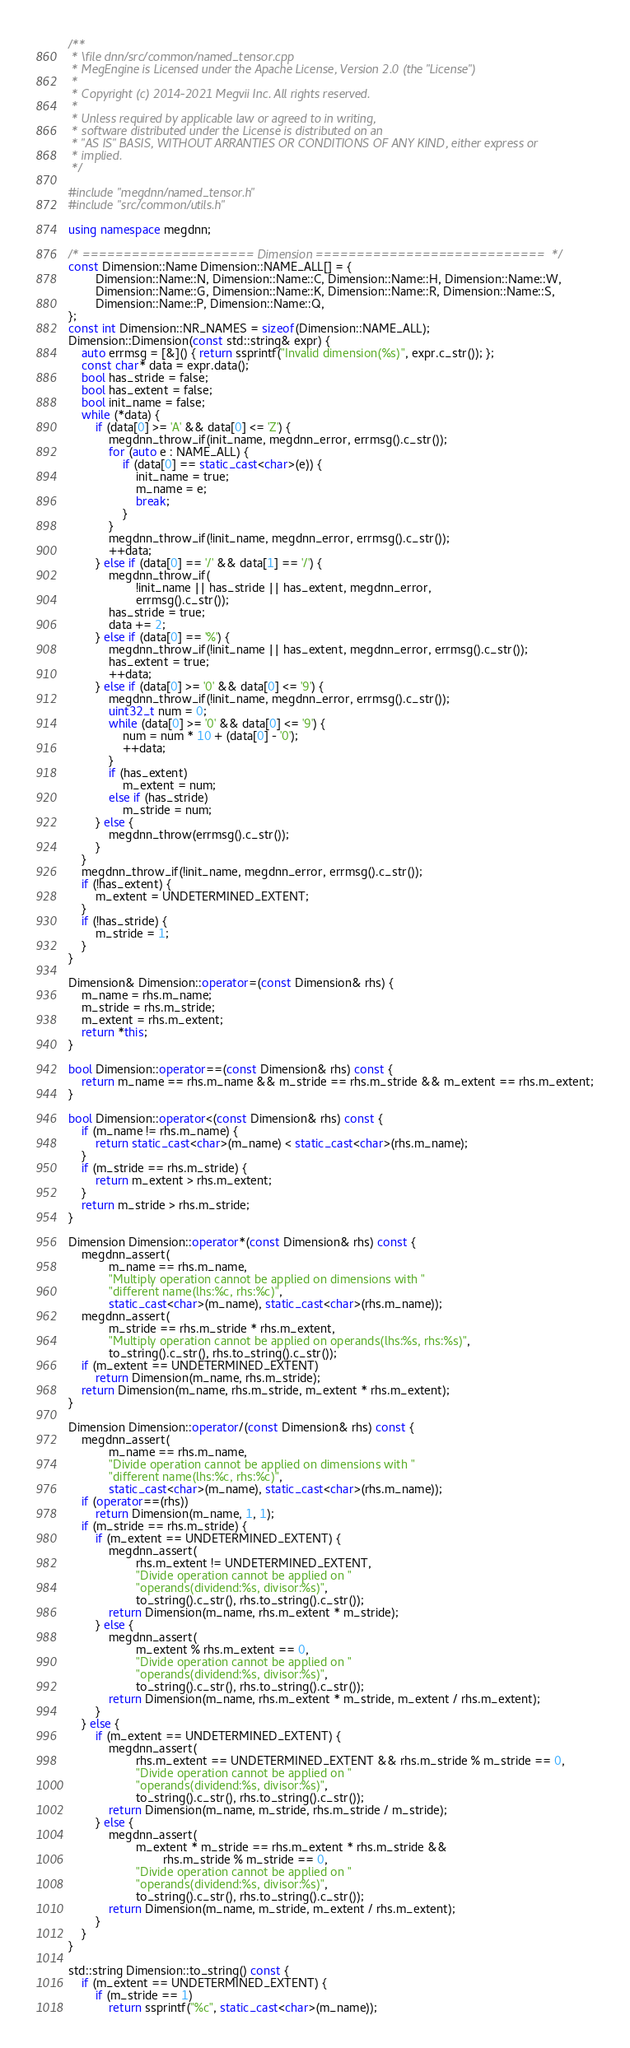<code> <loc_0><loc_0><loc_500><loc_500><_C++_>/**
 * \file dnn/src/common/named_tensor.cpp
 * MegEngine is Licensed under the Apache License, Version 2.0 (the "License")
 *
 * Copyright (c) 2014-2021 Megvii Inc. All rights reserved.
 *
 * Unless required by applicable law or agreed to in writing,
 * software distributed under the License is distributed on an
 * "AS IS" BASIS, WITHOUT ARRANTIES OR CONDITIONS OF ANY KIND, either express or
 * implied.
 */

#include "megdnn/named_tensor.h"
#include "src/common/utils.h"

using namespace megdnn;

/* ===================== Dimension ============================  */
const Dimension::Name Dimension::NAME_ALL[] = {
        Dimension::Name::N, Dimension::Name::C, Dimension::Name::H, Dimension::Name::W,
        Dimension::Name::G, Dimension::Name::K, Dimension::Name::R, Dimension::Name::S,
        Dimension::Name::P, Dimension::Name::Q,
};
const int Dimension::NR_NAMES = sizeof(Dimension::NAME_ALL);
Dimension::Dimension(const std::string& expr) {
    auto errmsg = [&]() { return ssprintf("Invalid dimension(%s)", expr.c_str()); };
    const char* data = expr.data();
    bool has_stride = false;
    bool has_extent = false;
    bool init_name = false;
    while (*data) {
        if (data[0] >= 'A' && data[0] <= 'Z') {
            megdnn_throw_if(init_name, megdnn_error, errmsg().c_str());
            for (auto e : NAME_ALL) {
                if (data[0] == static_cast<char>(e)) {
                    init_name = true;
                    m_name = e;
                    break;
                }
            }
            megdnn_throw_if(!init_name, megdnn_error, errmsg().c_str());
            ++data;
        } else if (data[0] == '/' && data[1] == '/') {
            megdnn_throw_if(
                    !init_name || has_stride || has_extent, megdnn_error,
                    errmsg().c_str());
            has_stride = true;
            data += 2;
        } else if (data[0] == '%') {
            megdnn_throw_if(!init_name || has_extent, megdnn_error, errmsg().c_str());
            has_extent = true;
            ++data;
        } else if (data[0] >= '0' && data[0] <= '9') {
            megdnn_throw_if(!init_name, megdnn_error, errmsg().c_str());
            uint32_t num = 0;
            while (data[0] >= '0' && data[0] <= '9') {
                num = num * 10 + (data[0] - '0');
                ++data;
            }
            if (has_extent)
                m_extent = num;
            else if (has_stride)
                m_stride = num;
        } else {
            megdnn_throw(errmsg().c_str());
        }
    }
    megdnn_throw_if(!init_name, megdnn_error, errmsg().c_str());
    if (!has_extent) {
        m_extent = UNDETERMINED_EXTENT;
    }
    if (!has_stride) {
        m_stride = 1;
    }
}

Dimension& Dimension::operator=(const Dimension& rhs) {
    m_name = rhs.m_name;
    m_stride = rhs.m_stride;
    m_extent = rhs.m_extent;
    return *this;
}

bool Dimension::operator==(const Dimension& rhs) const {
    return m_name == rhs.m_name && m_stride == rhs.m_stride && m_extent == rhs.m_extent;
}

bool Dimension::operator<(const Dimension& rhs) const {
    if (m_name != rhs.m_name) {
        return static_cast<char>(m_name) < static_cast<char>(rhs.m_name);
    }
    if (m_stride == rhs.m_stride) {
        return m_extent > rhs.m_extent;
    }
    return m_stride > rhs.m_stride;
}

Dimension Dimension::operator*(const Dimension& rhs) const {
    megdnn_assert(
            m_name == rhs.m_name,
            "Multiply operation cannot be applied on dimensions with "
            "different name(lhs:%c, rhs:%c)",
            static_cast<char>(m_name), static_cast<char>(rhs.m_name));
    megdnn_assert(
            m_stride == rhs.m_stride * rhs.m_extent,
            "Multiply operation cannot be applied on operands(lhs:%s, rhs:%s)",
            to_string().c_str(), rhs.to_string().c_str());
    if (m_extent == UNDETERMINED_EXTENT)
        return Dimension(m_name, rhs.m_stride);
    return Dimension(m_name, rhs.m_stride, m_extent * rhs.m_extent);
}

Dimension Dimension::operator/(const Dimension& rhs) const {
    megdnn_assert(
            m_name == rhs.m_name,
            "Divide operation cannot be applied on dimensions with "
            "different name(lhs:%c, rhs:%c)",
            static_cast<char>(m_name), static_cast<char>(rhs.m_name));
    if (operator==(rhs))
        return Dimension(m_name, 1, 1);
    if (m_stride == rhs.m_stride) {
        if (m_extent == UNDETERMINED_EXTENT) {
            megdnn_assert(
                    rhs.m_extent != UNDETERMINED_EXTENT,
                    "Divide operation cannot be applied on "
                    "operands(dividend:%s, divisor:%s)",
                    to_string().c_str(), rhs.to_string().c_str());
            return Dimension(m_name, rhs.m_extent * m_stride);
        } else {
            megdnn_assert(
                    m_extent % rhs.m_extent == 0,
                    "Divide operation cannot be applied on "
                    "operands(dividend:%s, divisor:%s)",
                    to_string().c_str(), rhs.to_string().c_str());
            return Dimension(m_name, rhs.m_extent * m_stride, m_extent / rhs.m_extent);
        }
    } else {
        if (m_extent == UNDETERMINED_EXTENT) {
            megdnn_assert(
                    rhs.m_extent == UNDETERMINED_EXTENT && rhs.m_stride % m_stride == 0,
                    "Divide operation cannot be applied on "
                    "operands(dividend:%s, divisor:%s)",
                    to_string().c_str(), rhs.to_string().c_str());
            return Dimension(m_name, m_stride, rhs.m_stride / m_stride);
        } else {
            megdnn_assert(
                    m_extent * m_stride == rhs.m_extent * rhs.m_stride &&
                            rhs.m_stride % m_stride == 0,
                    "Divide operation cannot be applied on "
                    "operands(dividend:%s, divisor:%s)",
                    to_string().c_str(), rhs.to_string().c_str());
            return Dimension(m_name, m_stride, m_extent / rhs.m_extent);
        }
    }
}

std::string Dimension::to_string() const {
    if (m_extent == UNDETERMINED_EXTENT) {
        if (m_stride == 1)
            return ssprintf("%c", static_cast<char>(m_name));</code> 